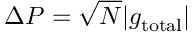Convert formula to latex. <formula><loc_0><loc_0><loc_500><loc_500>\Delta P = \sqrt { N } | g _ { t o t a l } |</formula> 